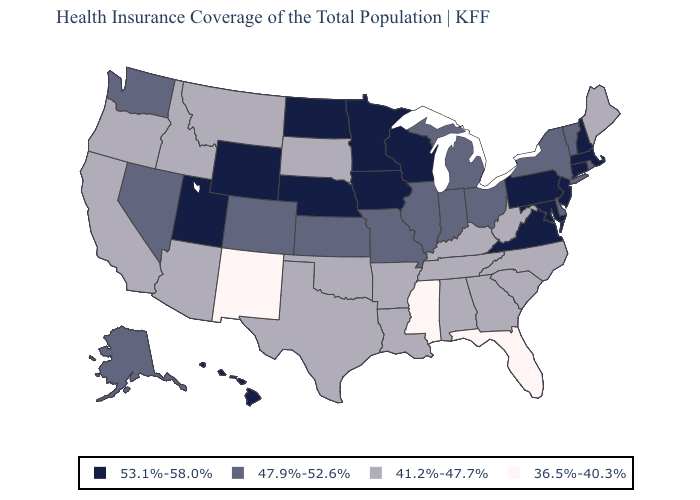Does Alabama have a lower value than Georgia?
Quick response, please. No. Among the states that border Montana , does North Dakota have the highest value?
Answer briefly. Yes. What is the highest value in states that border South Dakota?
Quick response, please. 53.1%-58.0%. Name the states that have a value in the range 47.9%-52.6%?
Write a very short answer. Alaska, Colorado, Delaware, Illinois, Indiana, Kansas, Michigan, Missouri, Nevada, New York, Ohio, Rhode Island, Vermont, Washington. What is the highest value in states that border Wyoming?
Short answer required. 53.1%-58.0%. Name the states that have a value in the range 41.2%-47.7%?
Concise answer only. Alabama, Arizona, Arkansas, California, Georgia, Idaho, Kentucky, Louisiana, Maine, Montana, North Carolina, Oklahoma, Oregon, South Carolina, South Dakota, Tennessee, Texas, West Virginia. Among the states that border Texas , which have the highest value?
Answer briefly. Arkansas, Louisiana, Oklahoma. Does Michigan have a higher value than Iowa?
Keep it brief. No. What is the highest value in the USA?
Give a very brief answer. 53.1%-58.0%. What is the lowest value in the Northeast?
Concise answer only. 41.2%-47.7%. Which states hav the highest value in the West?
Keep it brief. Hawaii, Utah, Wyoming. Which states hav the highest value in the West?
Short answer required. Hawaii, Utah, Wyoming. Among the states that border Utah , which have the lowest value?
Answer briefly. New Mexico. What is the value of Alabama?
Give a very brief answer. 41.2%-47.7%. Does Nebraska have the lowest value in the USA?
Give a very brief answer. No. 